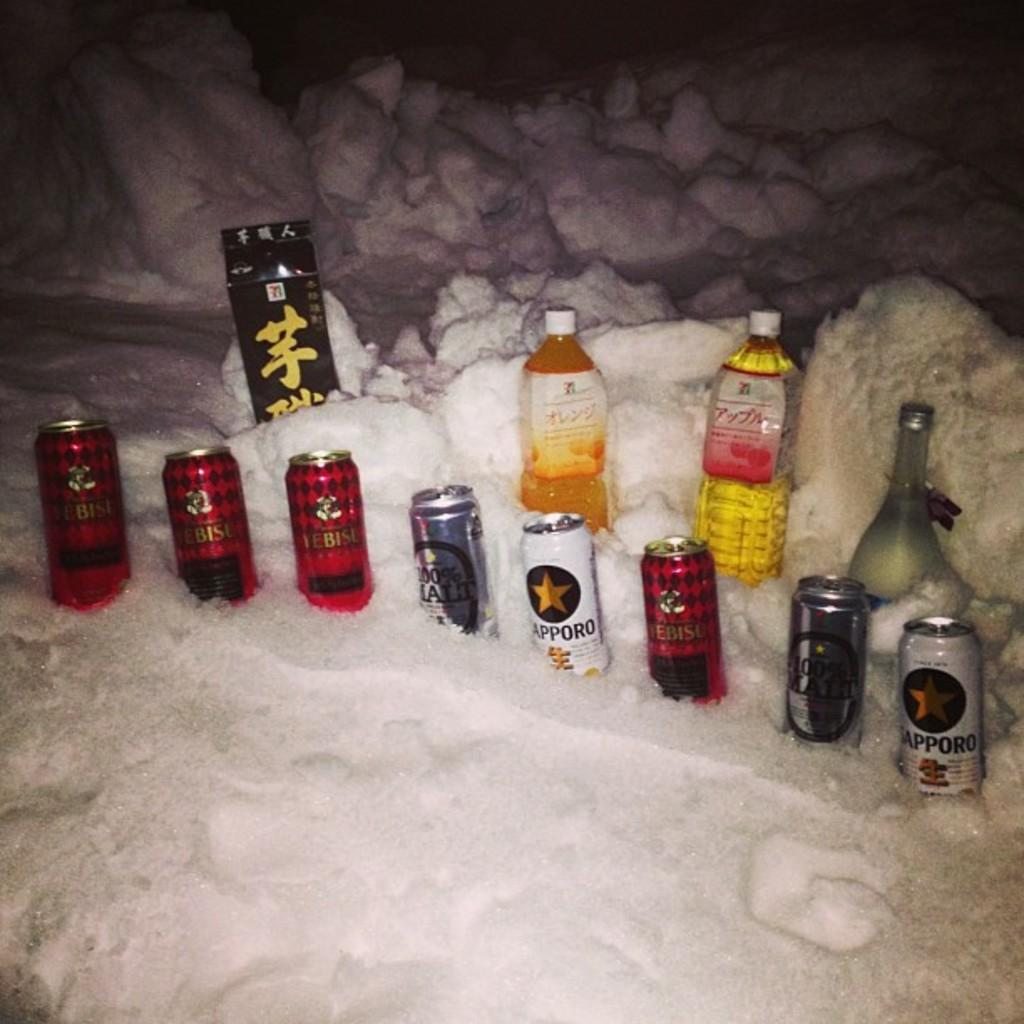<image>
Share a concise interpretation of the image provided. Several beers in the snow with one made by Sappro on the far right. 